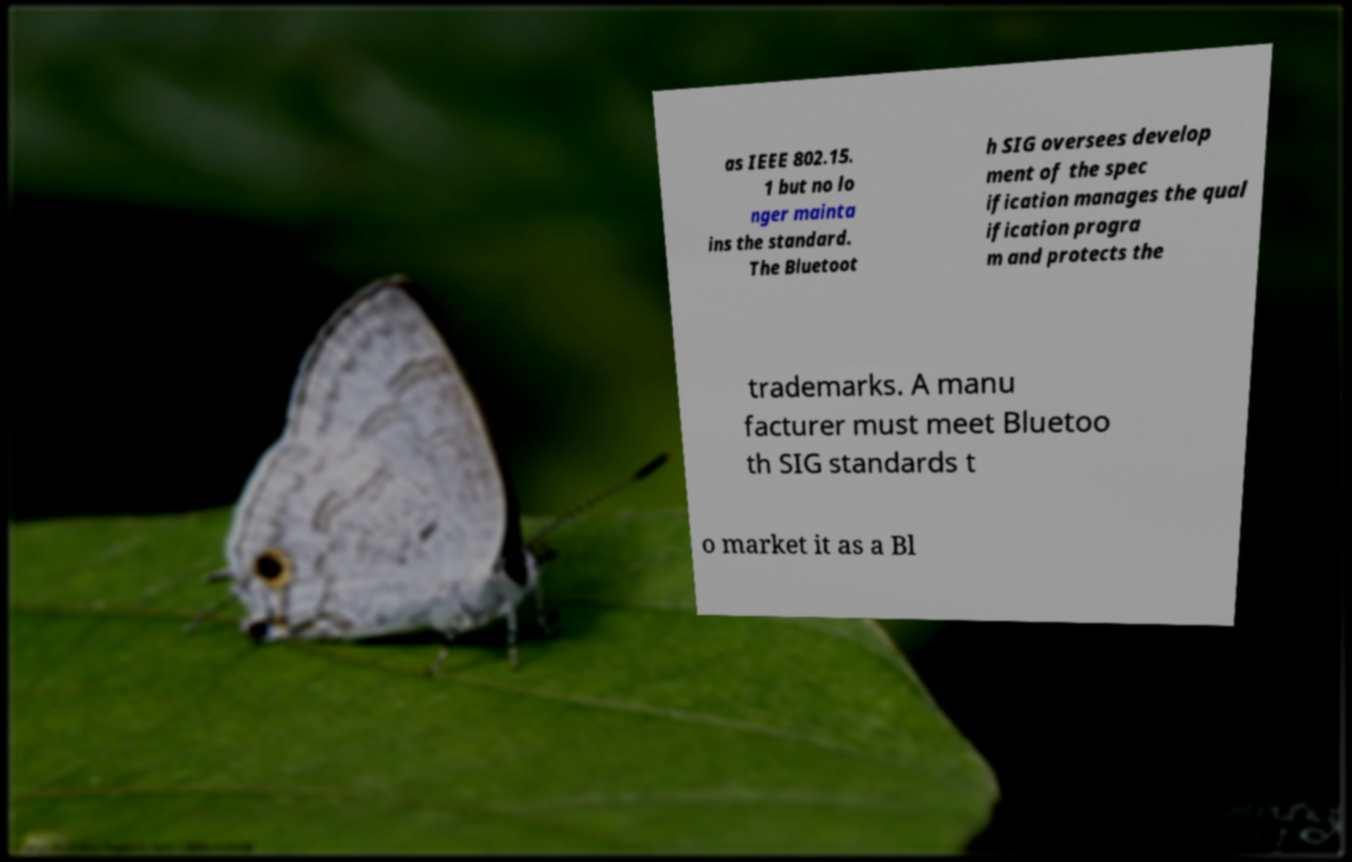There's text embedded in this image that I need extracted. Can you transcribe it verbatim? as IEEE 802.15. 1 but no lo nger mainta ins the standard. The Bluetoot h SIG oversees develop ment of the spec ification manages the qual ification progra m and protects the trademarks. A manu facturer must meet Bluetoo th SIG standards t o market it as a Bl 